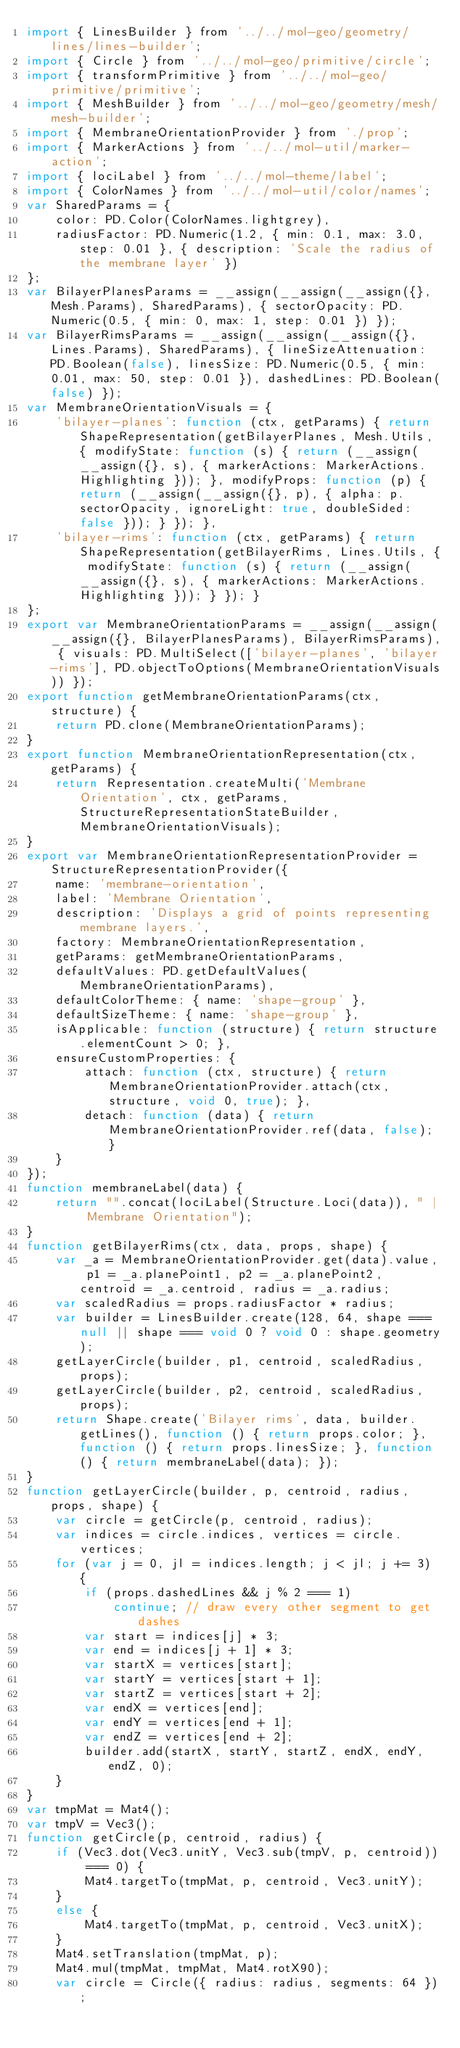<code> <loc_0><loc_0><loc_500><loc_500><_JavaScript_>import { LinesBuilder } from '../../mol-geo/geometry/lines/lines-builder';
import { Circle } from '../../mol-geo/primitive/circle';
import { transformPrimitive } from '../../mol-geo/primitive/primitive';
import { MeshBuilder } from '../../mol-geo/geometry/mesh/mesh-builder';
import { MembraneOrientationProvider } from './prop';
import { MarkerActions } from '../../mol-util/marker-action';
import { lociLabel } from '../../mol-theme/label';
import { ColorNames } from '../../mol-util/color/names';
var SharedParams = {
    color: PD.Color(ColorNames.lightgrey),
    radiusFactor: PD.Numeric(1.2, { min: 0.1, max: 3.0, step: 0.01 }, { description: 'Scale the radius of the membrane layer' })
};
var BilayerPlanesParams = __assign(__assign(__assign({}, Mesh.Params), SharedParams), { sectorOpacity: PD.Numeric(0.5, { min: 0, max: 1, step: 0.01 }) });
var BilayerRimsParams = __assign(__assign(__assign({}, Lines.Params), SharedParams), { lineSizeAttenuation: PD.Boolean(false), linesSize: PD.Numeric(0.5, { min: 0.01, max: 50, step: 0.01 }), dashedLines: PD.Boolean(false) });
var MembraneOrientationVisuals = {
    'bilayer-planes': function (ctx, getParams) { return ShapeRepresentation(getBilayerPlanes, Mesh.Utils, { modifyState: function (s) { return (__assign(__assign({}, s), { markerActions: MarkerActions.Highlighting })); }, modifyProps: function (p) { return (__assign(__assign({}, p), { alpha: p.sectorOpacity, ignoreLight: true, doubleSided: false })); } }); },
    'bilayer-rims': function (ctx, getParams) { return ShapeRepresentation(getBilayerRims, Lines.Utils, { modifyState: function (s) { return (__assign(__assign({}, s), { markerActions: MarkerActions.Highlighting })); } }); }
};
export var MembraneOrientationParams = __assign(__assign(__assign({}, BilayerPlanesParams), BilayerRimsParams), { visuals: PD.MultiSelect(['bilayer-planes', 'bilayer-rims'], PD.objectToOptions(MembraneOrientationVisuals)) });
export function getMembraneOrientationParams(ctx, structure) {
    return PD.clone(MembraneOrientationParams);
}
export function MembraneOrientationRepresentation(ctx, getParams) {
    return Representation.createMulti('Membrane Orientation', ctx, getParams, StructureRepresentationStateBuilder, MembraneOrientationVisuals);
}
export var MembraneOrientationRepresentationProvider = StructureRepresentationProvider({
    name: 'membrane-orientation',
    label: 'Membrane Orientation',
    description: 'Displays a grid of points representing membrane layers.',
    factory: MembraneOrientationRepresentation,
    getParams: getMembraneOrientationParams,
    defaultValues: PD.getDefaultValues(MembraneOrientationParams),
    defaultColorTheme: { name: 'shape-group' },
    defaultSizeTheme: { name: 'shape-group' },
    isApplicable: function (structure) { return structure.elementCount > 0; },
    ensureCustomProperties: {
        attach: function (ctx, structure) { return MembraneOrientationProvider.attach(ctx, structure, void 0, true); },
        detach: function (data) { return MembraneOrientationProvider.ref(data, false); }
    }
});
function membraneLabel(data) {
    return "".concat(lociLabel(Structure.Loci(data)), " | Membrane Orientation");
}
function getBilayerRims(ctx, data, props, shape) {
    var _a = MembraneOrientationProvider.get(data).value, p1 = _a.planePoint1, p2 = _a.planePoint2, centroid = _a.centroid, radius = _a.radius;
    var scaledRadius = props.radiusFactor * radius;
    var builder = LinesBuilder.create(128, 64, shape === null || shape === void 0 ? void 0 : shape.geometry);
    getLayerCircle(builder, p1, centroid, scaledRadius, props);
    getLayerCircle(builder, p2, centroid, scaledRadius, props);
    return Shape.create('Bilayer rims', data, builder.getLines(), function () { return props.color; }, function () { return props.linesSize; }, function () { return membraneLabel(data); });
}
function getLayerCircle(builder, p, centroid, radius, props, shape) {
    var circle = getCircle(p, centroid, radius);
    var indices = circle.indices, vertices = circle.vertices;
    for (var j = 0, jl = indices.length; j < jl; j += 3) {
        if (props.dashedLines && j % 2 === 1)
            continue; // draw every other segment to get dashes
        var start = indices[j] * 3;
        var end = indices[j + 1] * 3;
        var startX = vertices[start];
        var startY = vertices[start + 1];
        var startZ = vertices[start + 2];
        var endX = vertices[end];
        var endY = vertices[end + 1];
        var endZ = vertices[end + 2];
        builder.add(startX, startY, startZ, endX, endY, endZ, 0);
    }
}
var tmpMat = Mat4();
var tmpV = Vec3();
function getCircle(p, centroid, radius) {
    if (Vec3.dot(Vec3.unitY, Vec3.sub(tmpV, p, centroid)) === 0) {
        Mat4.targetTo(tmpMat, p, centroid, Vec3.unitY);
    }
    else {
        Mat4.targetTo(tmpMat, p, centroid, Vec3.unitX);
    }
    Mat4.setTranslation(tmpMat, p);
    Mat4.mul(tmpMat, tmpMat, Mat4.rotX90);
    var circle = Circle({ radius: radius, segments: 64 });</code> 